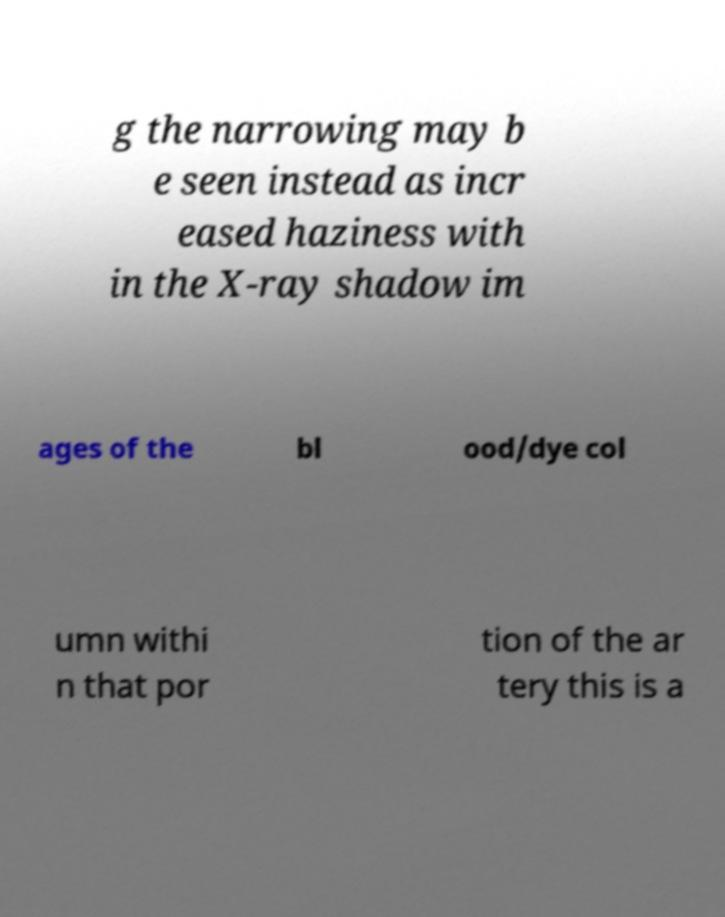Could you extract and type out the text from this image? g the narrowing may b e seen instead as incr eased haziness with in the X-ray shadow im ages of the bl ood/dye col umn withi n that por tion of the ar tery this is a 